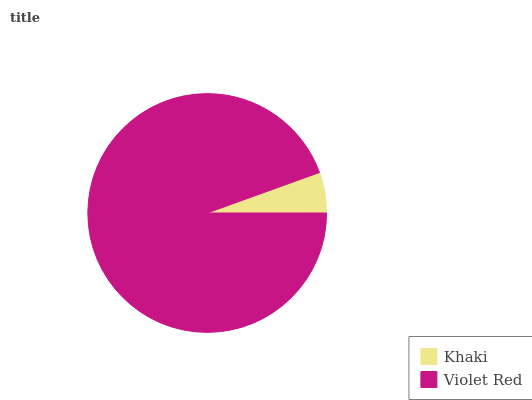Is Khaki the minimum?
Answer yes or no. Yes. Is Violet Red the maximum?
Answer yes or no. Yes. Is Violet Red the minimum?
Answer yes or no. No. Is Violet Red greater than Khaki?
Answer yes or no. Yes. Is Khaki less than Violet Red?
Answer yes or no. Yes. Is Khaki greater than Violet Red?
Answer yes or no. No. Is Violet Red less than Khaki?
Answer yes or no. No. Is Violet Red the high median?
Answer yes or no. Yes. Is Khaki the low median?
Answer yes or no. Yes. Is Khaki the high median?
Answer yes or no. No. Is Violet Red the low median?
Answer yes or no. No. 